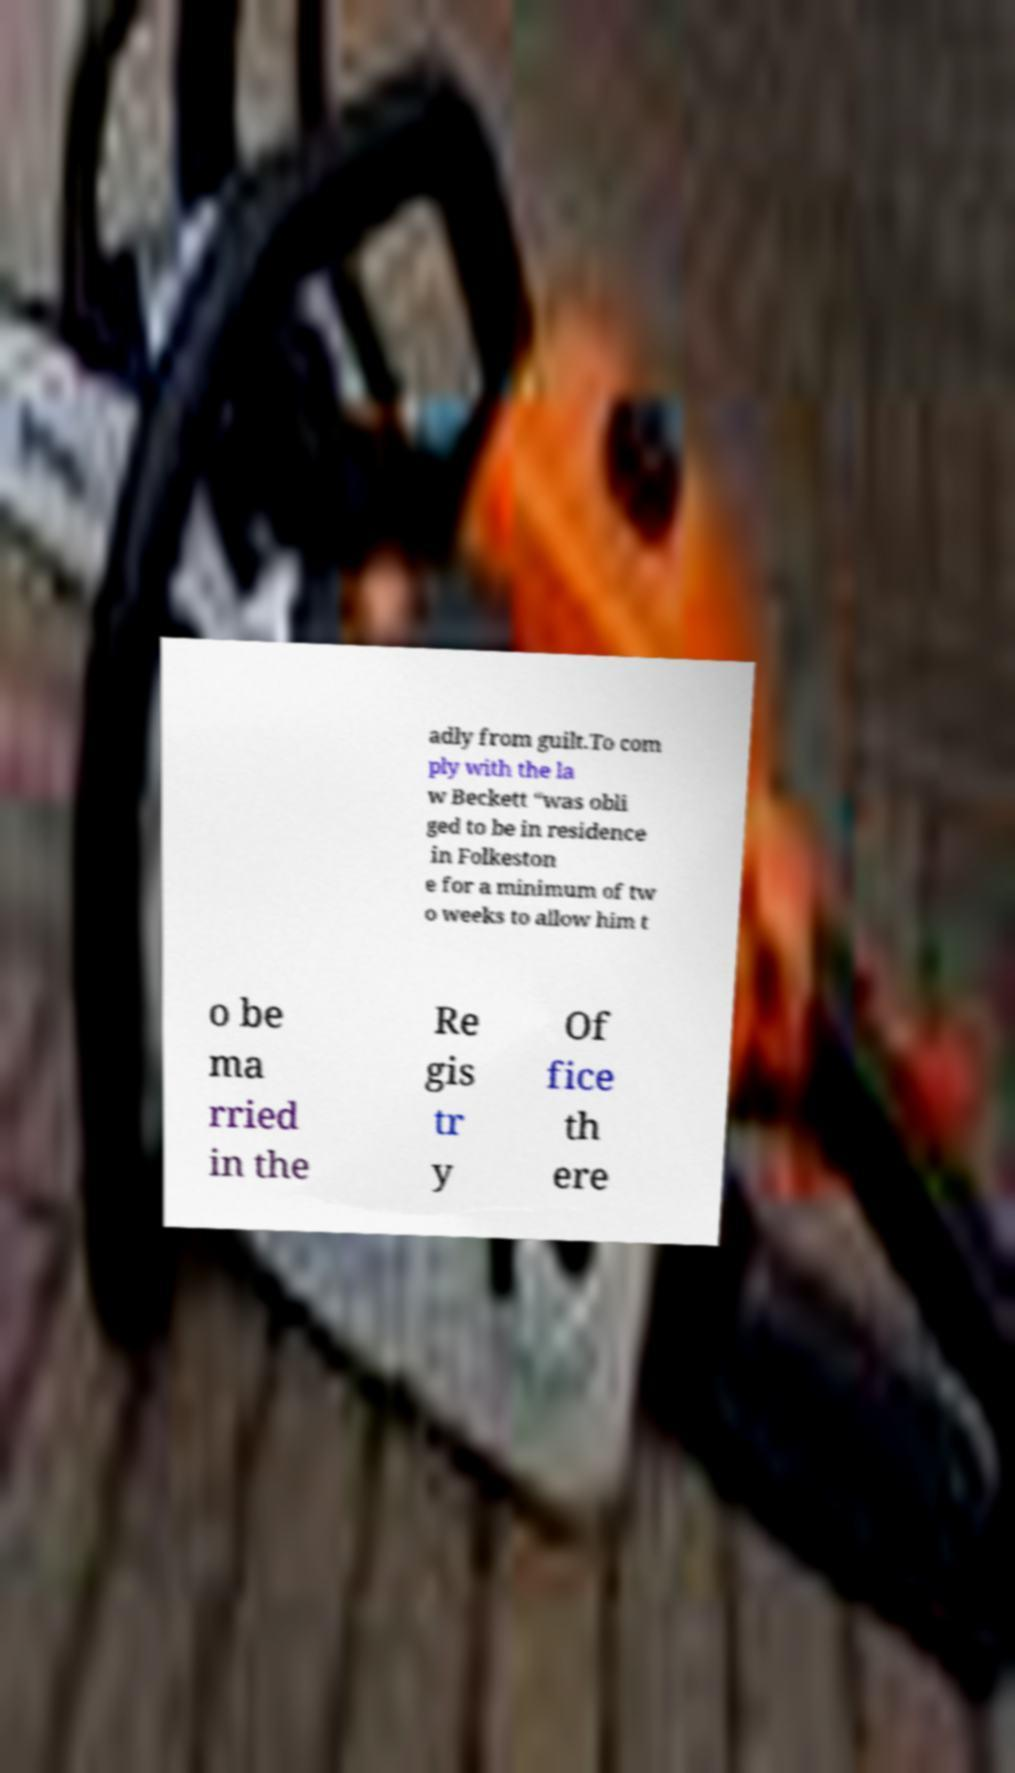Please read and relay the text visible in this image. What does it say? adly from guilt.To com ply with the la w Beckett “was obli ged to be in residence in Folkeston e for a minimum of tw o weeks to allow him t o be ma rried in the Re gis tr y Of fice th ere 